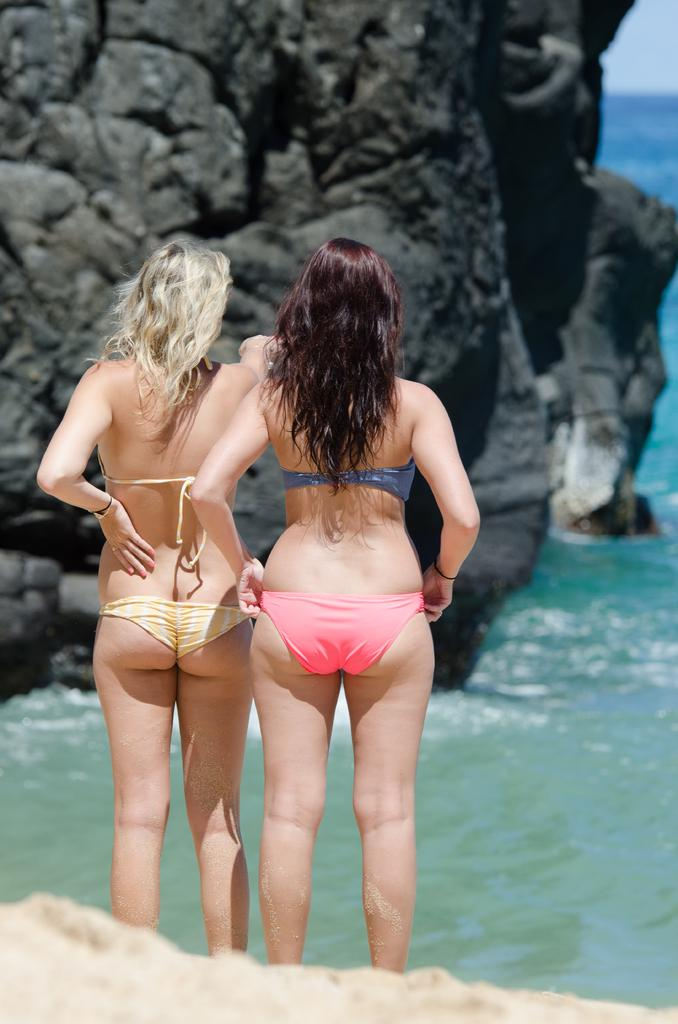How many women are in the image? There are two women standing in the image. What type of terrain is visible at the bottom of the image? There is sand visible at the bottom of the image. What can be seen in the background of the image? There is water and rocks in the background of the image. What type of sound can be heard coming from the dinosaurs in the image? There are no dinosaurs present in the image, so no such sound can be heard. 